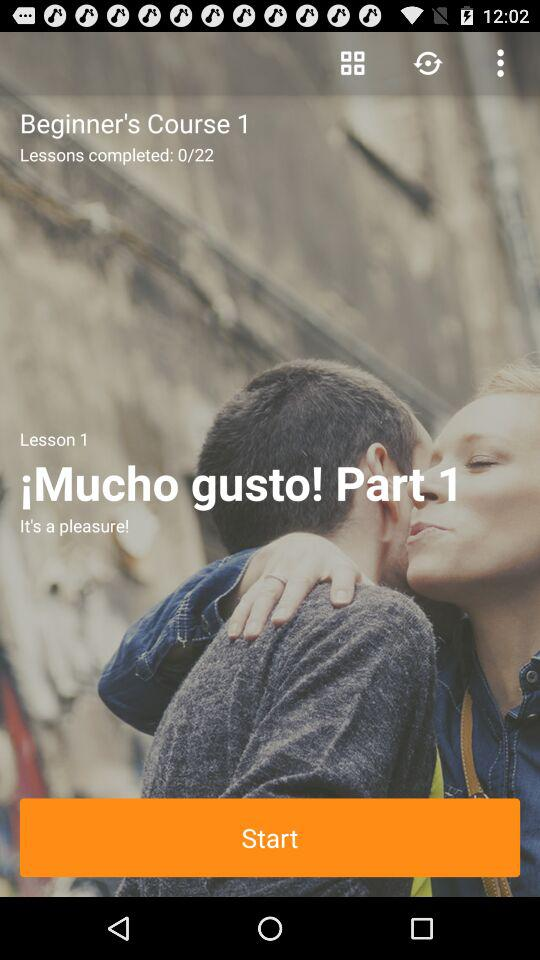How many lessons have I completed?
Answer the question using a single word or phrase. 0 